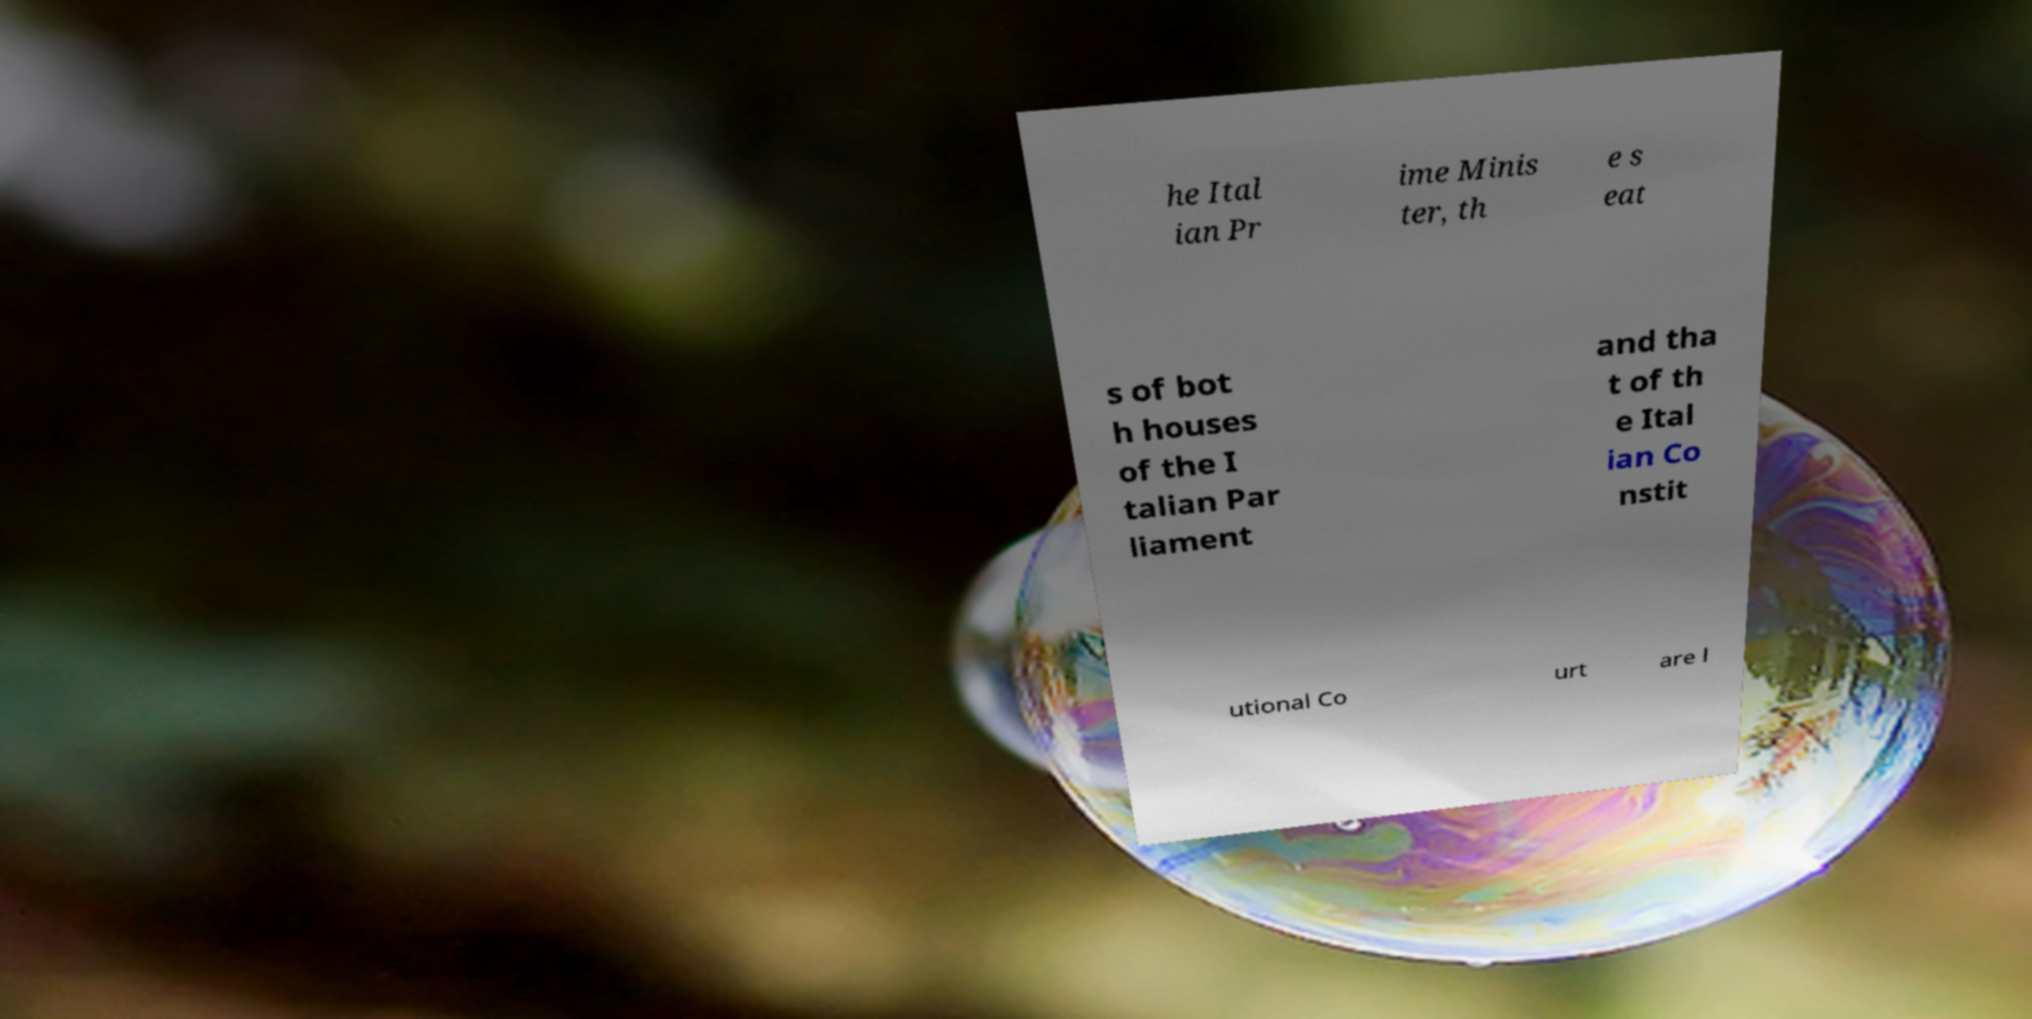Please read and relay the text visible in this image. What does it say? he Ital ian Pr ime Minis ter, th e s eat s of bot h houses of the I talian Par liament and tha t of th e Ital ian Co nstit utional Co urt are l 